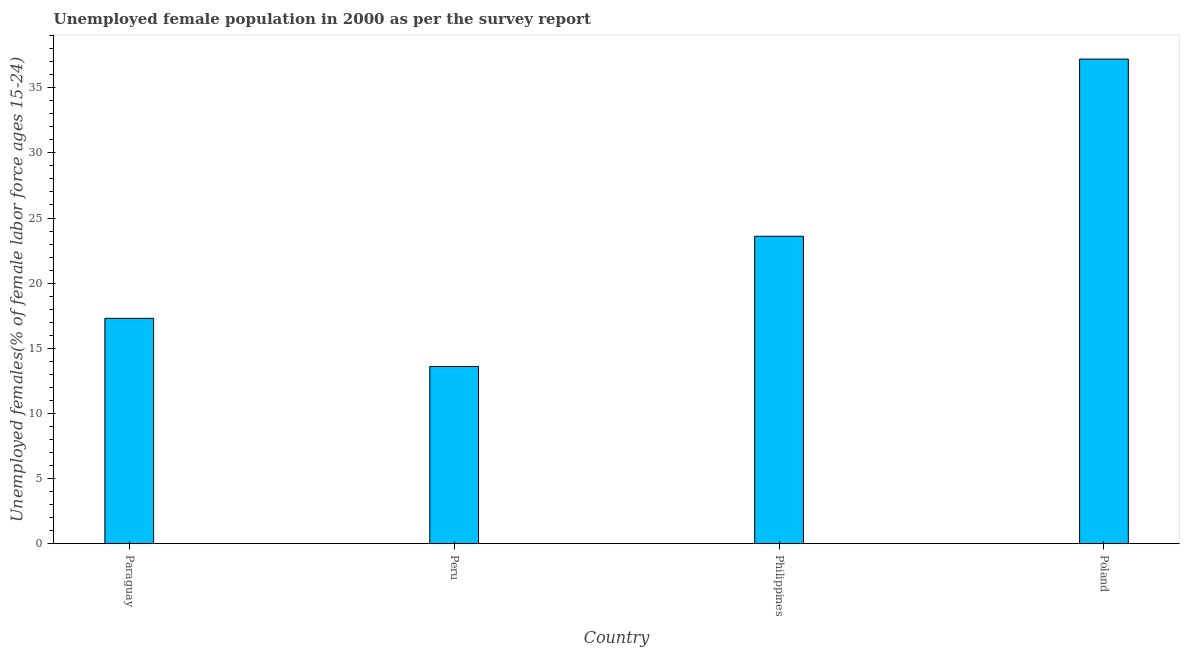Does the graph contain grids?
Offer a very short reply. No. What is the title of the graph?
Your answer should be very brief. Unemployed female population in 2000 as per the survey report. What is the label or title of the Y-axis?
Ensure brevity in your answer.  Unemployed females(% of female labor force ages 15-24). What is the unemployed female youth in Philippines?
Your response must be concise. 23.6. Across all countries, what is the maximum unemployed female youth?
Your answer should be compact. 37.2. Across all countries, what is the minimum unemployed female youth?
Make the answer very short. 13.6. In which country was the unemployed female youth minimum?
Make the answer very short. Peru. What is the sum of the unemployed female youth?
Offer a terse response. 91.7. What is the difference between the unemployed female youth in Peru and Philippines?
Make the answer very short. -10. What is the average unemployed female youth per country?
Provide a succinct answer. 22.93. What is the median unemployed female youth?
Make the answer very short. 20.45. In how many countries, is the unemployed female youth greater than 26 %?
Make the answer very short. 1. What is the ratio of the unemployed female youth in Paraguay to that in Peru?
Your response must be concise. 1.27. Is the unemployed female youth in Peru less than that in Philippines?
Your answer should be very brief. Yes. What is the difference between the highest and the second highest unemployed female youth?
Provide a short and direct response. 13.6. Is the sum of the unemployed female youth in Peru and Poland greater than the maximum unemployed female youth across all countries?
Your answer should be very brief. Yes. What is the difference between the highest and the lowest unemployed female youth?
Make the answer very short. 23.6. In how many countries, is the unemployed female youth greater than the average unemployed female youth taken over all countries?
Keep it short and to the point. 2. What is the difference between two consecutive major ticks on the Y-axis?
Give a very brief answer. 5. Are the values on the major ticks of Y-axis written in scientific E-notation?
Your response must be concise. No. What is the Unemployed females(% of female labor force ages 15-24) of Paraguay?
Offer a very short reply. 17.3. What is the Unemployed females(% of female labor force ages 15-24) in Peru?
Your answer should be compact. 13.6. What is the Unemployed females(% of female labor force ages 15-24) of Philippines?
Provide a short and direct response. 23.6. What is the Unemployed females(% of female labor force ages 15-24) of Poland?
Your response must be concise. 37.2. What is the difference between the Unemployed females(% of female labor force ages 15-24) in Paraguay and Philippines?
Provide a short and direct response. -6.3. What is the difference between the Unemployed females(% of female labor force ages 15-24) in Paraguay and Poland?
Your answer should be very brief. -19.9. What is the difference between the Unemployed females(% of female labor force ages 15-24) in Peru and Philippines?
Offer a very short reply. -10. What is the difference between the Unemployed females(% of female labor force ages 15-24) in Peru and Poland?
Your answer should be compact. -23.6. What is the difference between the Unemployed females(% of female labor force ages 15-24) in Philippines and Poland?
Provide a succinct answer. -13.6. What is the ratio of the Unemployed females(% of female labor force ages 15-24) in Paraguay to that in Peru?
Offer a terse response. 1.27. What is the ratio of the Unemployed females(% of female labor force ages 15-24) in Paraguay to that in Philippines?
Keep it short and to the point. 0.73. What is the ratio of the Unemployed females(% of female labor force ages 15-24) in Paraguay to that in Poland?
Make the answer very short. 0.47. What is the ratio of the Unemployed females(% of female labor force ages 15-24) in Peru to that in Philippines?
Keep it short and to the point. 0.58. What is the ratio of the Unemployed females(% of female labor force ages 15-24) in Peru to that in Poland?
Ensure brevity in your answer.  0.37. What is the ratio of the Unemployed females(% of female labor force ages 15-24) in Philippines to that in Poland?
Your answer should be compact. 0.63. 